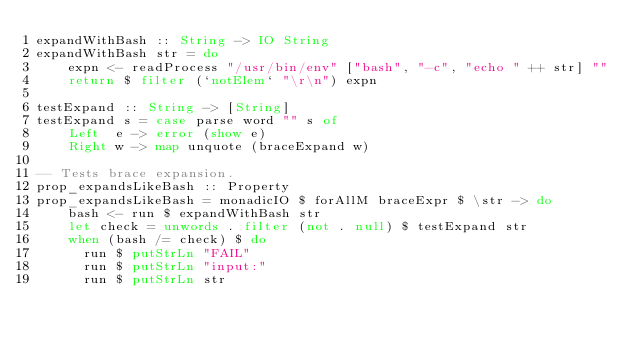<code> <loc_0><loc_0><loc_500><loc_500><_Haskell_>expandWithBash :: String -> IO String
expandWithBash str = do
    expn <- readProcess "/usr/bin/env" ["bash", "-c", "echo " ++ str] ""
    return $ filter (`notElem` "\r\n") expn

testExpand :: String -> [String]
testExpand s = case parse word "" s of
    Left  e -> error (show e)
    Right w -> map unquote (braceExpand w)

-- Tests brace expansion.
prop_expandsLikeBash :: Property
prop_expandsLikeBash = monadicIO $ forAllM braceExpr $ \str -> do
    bash <- run $ expandWithBash str
    let check = unwords . filter (not . null) $ testExpand str
    when (bash /= check) $ do
      run $ putStrLn "FAIL"
      run $ putStrLn "input:"
      run $ putStrLn str</code> 